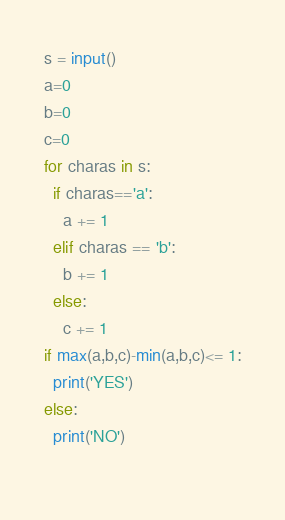Convert code to text. <code><loc_0><loc_0><loc_500><loc_500><_Python_>s = input()
a=0
b=0
c=0
for charas in s:
  if charas=='a':
    a += 1
  elif charas == 'b':
    b += 1
  else:
    c += 1
if max(a,b,c)-min(a,b,c)<= 1:
  print('YES')
else:
  print('NO')
        </code> 